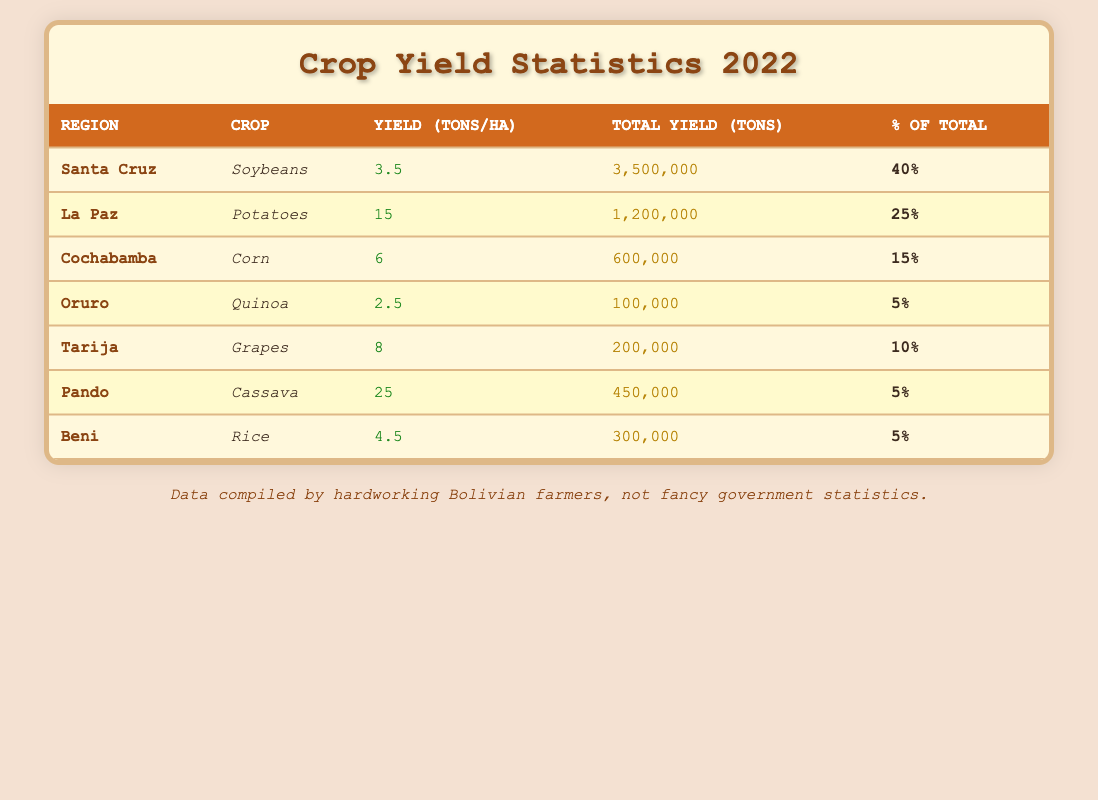What is the total yield of soybeans in Santa Cruz? The table lists the total yield of soybeans in Santa Cruz as 3,500,000 tons.
Answer: 3,500,000 tons Which crop has the highest yield per hectare, and what is that yield? The table shows that the crop with the highest yield per hectare is cassava in Pando, with a yield of 25 tons per hectare.
Answer: Cassava; 25 tons/ha What percentage of the total crop yield does La Paz contribute? According to the table, La Paz contributes 25% of the total crop yield.
Answer: 25% How many tons of corn are produced in Cochabamba? The table indicates that Cochabamba produces 600,000 tons of corn.
Answer: 600,000 tons What is the difference in total yield between Santa Cruz and Oruro? The total yield for Santa Cruz is 3,500,000 tons, and for Oruro, it is 100,000 tons. The difference is 3,500,000 - 100,000 = 3,400,000 tons.
Answer: 3,400,000 tons How much quinoa is produced compared to grapes? Oruro produces 100,000 tons of quinoa, while Tarija produces 200,000 tons of grapes. The difference is 200,000 - 100,000 = 100,000 tons more grapes than quinoa.
Answer: 100,000 tons more grapes If we average the percentage contributions of the crops, what would that be? The contributions are 40%, 25%, 15%, 5%, 10%, 5%, and 5%. The average is (40 + 25 + 15 + 5 + 10 + 5 + 5) / 7 = 9.29%.
Answer: Approximately 9.29% Is the yield per hectare of potatoes in La Paz greater than the yield per hectare of soybeans in Santa Cruz? La Paz has 15 tons per hectare for potatoes, while Santa Cruz has 3.5 tons per hectare for soybeans. Thus, 15 > 3.5 is true.
Answer: Yes Which region has the lowest total crop yield, and what is that yield? The region with the lowest total crop yield is Oruro, with 100,000 tons for quinoa.
Answer: Oruro; 100,000 tons How much of Bolivia's total crop yield is produced by the three regions with the highest yields combined? The three highest yields are from Santa Cruz (3,500,000 tons), La Paz (1,200,000 tons), and Cochabamba (600,000 tons). Their combined yield is: 3,500,000 + 1,200,000 + 600,000 = 5,300,000 tons.
Answer: 5,300,000 tons 